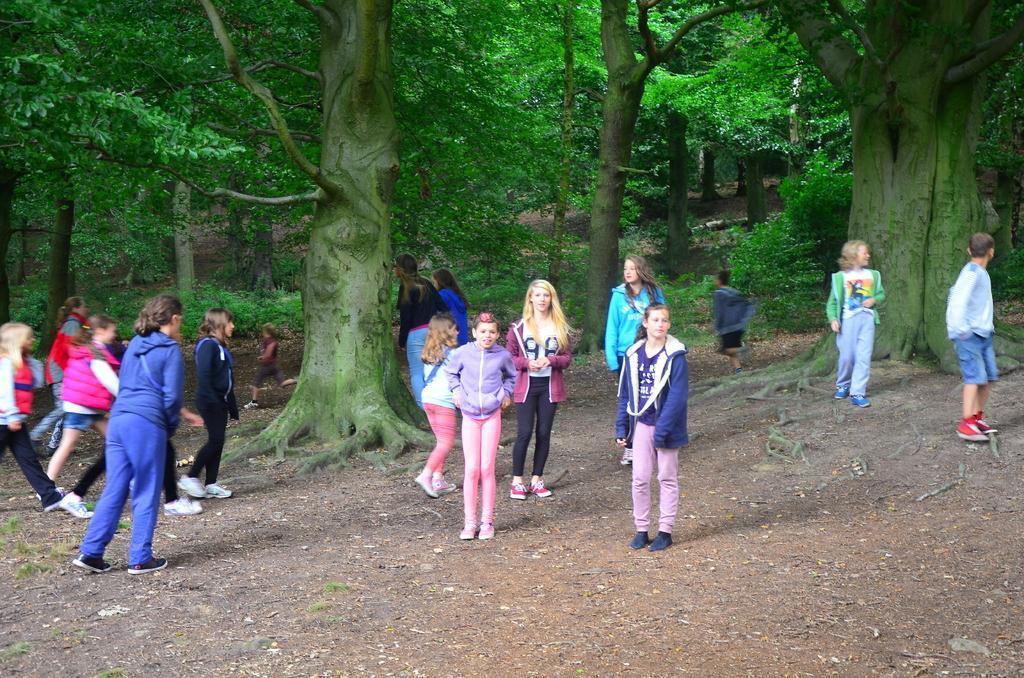In one or two sentences, can you explain what this image depicts? In this image we can see a group of people on the ground. In that some are running and the other are standing on the ground. We can also see the bark of the trees, some plants and a group of trees. 